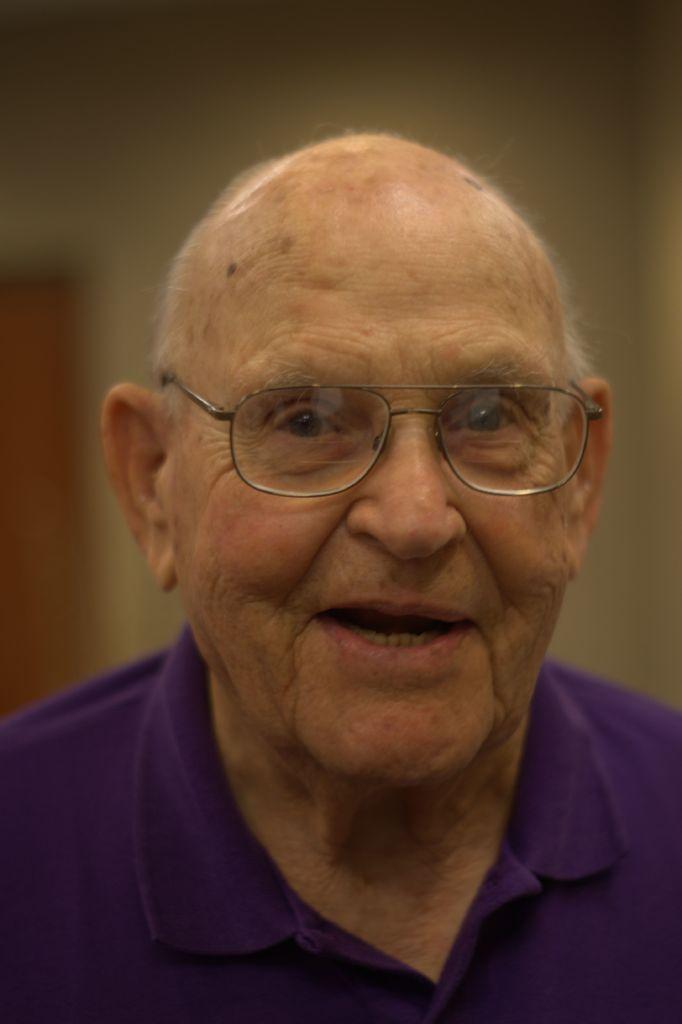In one or two sentences, can you explain what this image depicts? In this picture we can see a man with spectacles. Behind the man, there is a blurred background. 